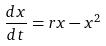Convert formula to latex. <formula><loc_0><loc_0><loc_500><loc_500>\frac { d x } { d t } = r x - x ^ { 2 }</formula> 